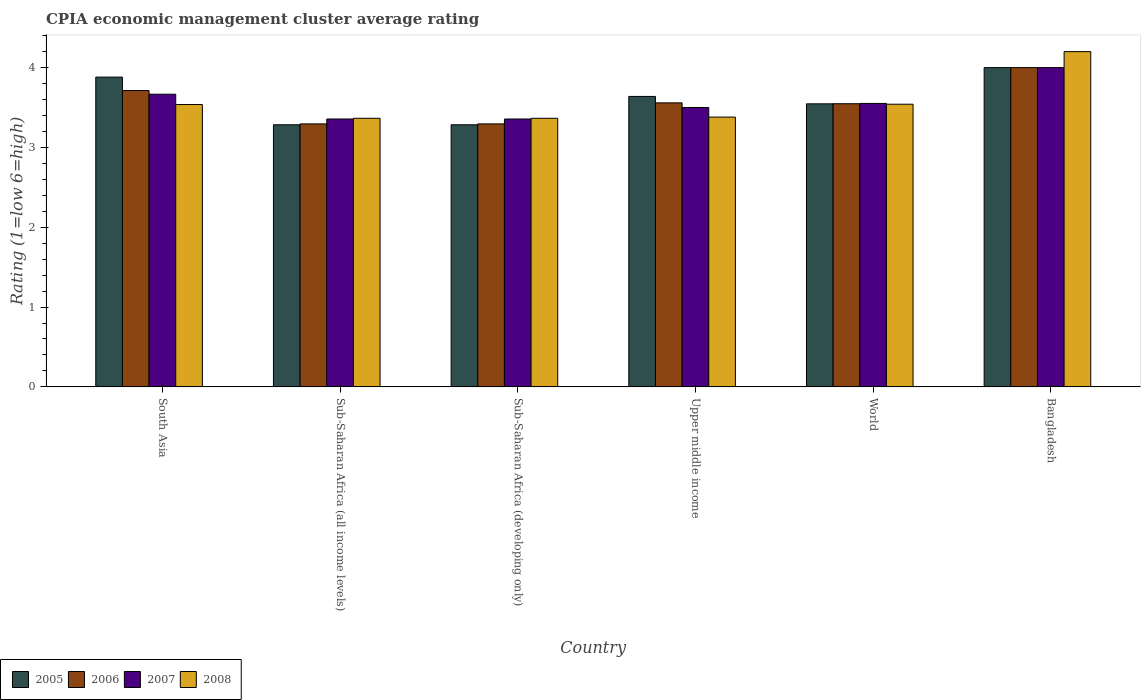How many different coloured bars are there?
Provide a succinct answer. 4. How many groups of bars are there?
Keep it short and to the point. 6. Are the number of bars per tick equal to the number of legend labels?
Your answer should be very brief. Yes. Are the number of bars on each tick of the X-axis equal?
Offer a terse response. Yes. How many bars are there on the 5th tick from the left?
Your response must be concise. 4. How many bars are there on the 2nd tick from the right?
Provide a succinct answer. 4. Across all countries, what is the maximum CPIA rating in 2007?
Your answer should be compact. 4. Across all countries, what is the minimum CPIA rating in 2008?
Make the answer very short. 3.36. In which country was the CPIA rating in 2008 maximum?
Give a very brief answer. Bangladesh. In which country was the CPIA rating in 2006 minimum?
Keep it short and to the point. Sub-Saharan Africa (all income levels). What is the total CPIA rating in 2006 in the graph?
Make the answer very short. 21.41. What is the difference between the CPIA rating in 2005 in South Asia and that in World?
Keep it short and to the point. 0.33. What is the difference between the CPIA rating in 2006 in Sub-Saharan Africa (developing only) and the CPIA rating in 2007 in Bangladesh?
Keep it short and to the point. -0.71. What is the average CPIA rating in 2006 per country?
Ensure brevity in your answer.  3.57. What is the difference between the CPIA rating of/in 2006 and CPIA rating of/in 2005 in Sub-Saharan Africa (developing only)?
Your answer should be compact. 0.01. In how many countries, is the CPIA rating in 2007 greater than 4.2?
Offer a very short reply. 0. What is the ratio of the CPIA rating in 2006 in Bangladesh to that in Sub-Saharan Africa (all income levels)?
Provide a succinct answer. 1.21. Is the CPIA rating in 2007 in South Asia less than that in Sub-Saharan Africa (all income levels)?
Give a very brief answer. No. Is the difference between the CPIA rating in 2006 in South Asia and World greater than the difference between the CPIA rating in 2005 in South Asia and World?
Your response must be concise. No. What is the difference between the highest and the second highest CPIA rating in 2005?
Offer a terse response. -0.24. What is the difference between the highest and the lowest CPIA rating in 2005?
Your answer should be compact. 0.72. Is the sum of the CPIA rating in 2007 in Sub-Saharan Africa (developing only) and Upper middle income greater than the maximum CPIA rating in 2006 across all countries?
Ensure brevity in your answer.  Yes. Is it the case that in every country, the sum of the CPIA rating in 2008 and CPIA rating in 2005 is greater than the sum of CPIA rating in 2007 and CPIA rating in 2006?
Your answer should be very brief. No. Is it the case that in every country, the sum of the CPIA rating in 2008 and CPIA rating in 2006 is greater than the CPIA rating in 2007?
Ensure brevity in your answer.  Yes. What is the difference between two consecutive major ticks on the Y-axis?
Your answer should be compact. 1. How many legend labels are there?
Keep it short and to the point. 4. How are the legend labels stacked?
Your answer should be compact. Horizontal. What is the title of the graph?
Make the answer very short. CPIA economic management cluster average rating. Does "1967" appear as one of the legend labels in the graph?
Ensure brevity in your answer.  No. What is the label or title of the X-axis?
Offer a very short reply. Country. What is the label or title of the Y-axis?
Your answer should be compact. Rating (1=low 6=high). What is the Rating (1=low 6=high) of 2005 in South Asia?
Offer a very short reply. 3.88. What is the Rating (1=low 6=high) in 2006 in South Asia?
Give a very brief answer. 3.71. What is the Rating (1=low 6=high) in 2007 in South Asia?
Ensure brevity in your answer.  3.67. What is the Rating (1=low 6=high) in 2008 in South Asia?
Ensure brevity in your answer.  3.54. What is the Rating (1=low 6=high) in 2005 in Sub-Saharan Africa (all income levels)?
Offer a very short reply. 3.28. What is the Rating (1=low 6=high) of 2006 in Sub-Saharan Africa (all income levels)?
Keep it short and to the point. 3.29. What is the Rating (1=low 6=high) of 2007 in Sub-Saharan Africa (all income levels)?
Make the answer very short. 3.36. What is the Rating (1=low 6=high) in 2008 in Sub-Saharan Africa (all income levels)?
Your answer should be very brief. 3.36. What is the Rating (1=low 6=high) of 2005 in Sub-Saharan Africa (developing only)?
Provide a short and direct response. 3.28. What is the Rating (1=low 6=high) in 2006 in Sub-Saharan Africa (developing only)?
Ensure brevity in your answer.  3.29. What is the Rating (1=low 6=high) in 2007 in Sub-Saharan Africa (developing only)?
Your answer should be compact. 3.36. What is the Rating (1=low 6=high) in 2008 in Sub-Saharan Africa (developing only)?
Provide a short and direct response. 3.36. What is the Rating (1=low 6=high) in 2005 in Upper middle income?
Offer a terse response. 3.64. What is the Rating (1=low 6=high) of 2006 in Upper middle income?
Provide a succinct answer. 3.56. What is the Rating (1=low 6=high) of 2008 in Upper middle income?
Keep it short and to the point. 3.38. What is the Rating (1=low 6=high) in 2005 in World?
Your answer should be very brief. 3.55. What is the Rating (1=low 6=high) in 2006 in World?
Provide a succinct answer. 3.55. What is the Rating (1=low 6=high) of 2007 in World?
Give a very brief answer. 3.55. What is the Rating (1=low 6=high) in 2008 in World?
Your answer should be very brief. 3.54. What is the Rating (1=low 6=high) in 2007 in Bangladesh?
Your response must be concise. 4. What is the Rating (1=low 6=high) of 2008 in Bangladesh?
Give a very brief answer. 4.2. Across all countries, what is the maximum Rating (1=low 6=high) of 2008?
Your answer should be compact. 4.2. Across all countries, what is the minimum Rating (1=low 6=high) in 2005?
Your response must be concise. 3.28. Across all countries, what is the minimum Rating (1=low 6=high) of 2006?
Offer a very short reply. 3.29. Across all countries, what is the minimum Rating (1=low 6=high) of 2007?
Offer a very short reply. 3.36. Across all countries, what is the minimum Rating (1=low 6=high) in 2008?
Your answer should be very brief. 3.36. What is the total Rating (1=low 6=high) in 2005 in the graph?
Make the answer very short. 21.63. What is the total Rating (1=low 6=high) in 2006 in the graph?
Offer a terse response. 21.41. What is the total Rating (1=low 6=high) of 2007 in the graph?
Make the answer very short. 21.43. What is the total Rating (1=low 6=high) in 2008 in the graph?
Give a very brief answer. 21.39. What is the difference between the Rating (1=low 6=high) in 2005 in South Asia and that in Sub-Saharan Africa (all income levels)?
Ensure brevity in your answer.  0.6. What is the difference between the Rating (1=low 6=high) of 2006 in South Asia and that in Sub-Saharan Africa (all income levels)?
Provide a succinct answer. 0.42. What is the difference between the Rating (1=low 6=high) in 2007 in South Asia and that in Sub-Saharan Africa (all income levels)?
Your answer should be very brief. 0.31. What is the difference between the Rating (1=low 6=high) of 2008 in South Asia and that in Sub-Saharan Africa (all income levels)?
Keep it short and to the point. 0.17. What is the difference between the Rating (1=low 6=high) in 2005 in South Asia and that in Sub-Saharan Africa (developing only)?
Your answer should be very brief. 0.6. What is the difference between the Rating (1=low 6=high) in 2006 in South Asia and that in Sub-Saharan Africa (developing only)?
Ensure brevity in your answer.  0.42. What is the difference between the Rating (1=low 6=high) in 2007 in South Asia and that in Sub-Saharan Africa (developing only)?
Your answer should be compact. 0.31. What is the difference between the Rating (1=low 6=high) of 2008 in South Asia and that in Sub-Saharan Africa (developing only)?
Make the answer very short. 0.17. What is the difference between the Rating (1=low 6=high) in 2005 in South Asia and that in Upper middle income?
Provide a short and direct response. 0.24. What is the difference between the Rating (1=low 6=high) of 2006 in South Asia and that in Upper middle income?
Keep it short and to the point. 0.15. What is the difference between the Rating (1=low 6=high) in 2008 in South Asia and that in Upper middle income?
Provide a short and direct response. 0.16. What is the difference between the Rating (1=low 6=high) in 2005 in South Asia and that in World?
Provide a succinct answer. 0.33. What is the difference between the Rating (1=low 6=high) of 2006 in South Asia and that in World?
Keep it short and to the point. 0.17. What is the difference between the Rating (1=low 6=high) of 2007 in South Asia and that in World?
Offer a terse response. 0.12. What is the difference between the Rating (1=low 6=high) of 2008 in South Asia and that in World?
Offer a very short reply. -0. What is the difference between the Rating (1=low 6=high) of 2005 in South Asia and that in Bangladesh?
Your answer should be very brief. -0.12. What is the difference between the Rating (1=low 6=high) of 2006 in South Asia and that in Bangladesh?
Your answer should be very brief. -0.29. What is the difference between the Rating (1=low 6=high) in 2007 in South Asia and that in Bangladesh?
Provide a short and direct response. -0.33. What is the difference between the Rating (1=low 6=high) of 2008 in South Asia and that in Bangladesh?
Your answer should be very brief. -0.66. What is the difference between the Rating (1=low 6=high) of 2006 in Sub-Saharan Africa (all income levels) and that in Sub-Saharan Africa (developing only)?
Your response must be concise. 0. What is the difference between the Rating (1=low 6=high) in 2005 in Sub-Saharan Africa (all income levels) and that in Upper middle income?
Offer a very short reply. -0.36. What is the difference between the Rating (1=low 6=high) of 2006 in Sub-Saharan Africa (all income levels) and that in Upper middle income?
Offer a very short reply. -0.26. What is the difference between the Rating (1=low 6=high) in 2007 in Sub-Saharan Africa (all income levels) and that in Upper middle income?
Offer a terse response. -0.14. What is the difference between the Rating (1=low 6=high) of 2008 in Sub-Saharan Africa (all income levels) and that in Upper middle income?
Make the answer very short. -0.02. What is the difference between the Rating (1=low 6=high) of 2005 in Sub-Saharan Africa (all income levels) and that in World?
Offer a very short reply. -0.26. What is the difference between the Rating (1=low 6=high) in 2006 in Sub-Saharan Africa (all income levels) and that in World?
Ensure brevity in your answer.  -0.25. What is the difference between the Rating (1=low 6=high) of 2007 in Sub-Saharan Africa (all income levels) and that in World?
Offer a very short reply. -0.2. What is the difference between the Rating (1=low 6=high) of 2008 in Sub-Saharan Africa (all income levels) and that in World?
Make the answer very short. -0.18. What is the difference between the Rating (1=low 6=high) in 2005 in Sub-Saharan Africa (all income levels) and that in Bangladesh?
Make the answer very short. -0.72. What is the difference between the Rating (1=low 6=high) in 2006 in Sub-Saharan Africa (all income levels) and that in Bangladesh?
Your answer should be compact. -0.71. What is the difference between the Rating (1=low 6=high) of 2007 in Sub-Saharan Africa (all income levels) and that in Bangladesh?
Your response must be concise. -0.64. What is the difference between the Rating (1=low 6=high) in 2008 in Sub-Saharan Africa (all income levels) and that in Bangladesh?
Keep it short and to the point. -0.84. What is the difference between the Rating (1=low 6=high) of 2005 in Sub-Saharan Africa (developing only) and that in Upper middle income?
Your answer should be very brief. -0.36. What is the difference between the Rating (1=low 6=high) of 2006 in Sub-Saharan Africa (developing only) and that in Upper middle income?
Provide a succinct answer. -0.26. What is the difference between the Rating (1=low 6=high) of 2007 in Sub-Saharan Africa (developing only) and that in Upper middle income?
Keep it short and to the point. -0.14. What is the difference between the Rating (1=low 6=high) in 2008 in Sub-Saharan Africa (developing only) and that in Upper middle income?
Your answer should be compact. -0.02. What is the difference between the Rating (1=low 6=high) of 2005 in Sub-Saharan Africa (developing only) and that in World?
Your answer should be compact. -0.26. What is the difference between the Rating (1=low 6=high) in 2006 in Sub-Saharan Africa (developing only) and that in World?
Offer a terse response. -0.25. What is the difference between the Rating (1=low 6=high) in 2007 in Sub-Saharan Africa (developing only) and that in World?
Provide a short and direct response. -0.2. What is the difference between the Rating (1=low 6=high) of 2008 in Sub-Saharan Africa (developing only) and that in World?
Provide a short and direct response. -0.18. What is the difference between the Rating (1=low 6=high) of 2005 in Sub-Saharan Africa (developing only) and that in Bangladesh?
Offer a terse response. -0.72. What is the difference between the Rating (1=low 6=high) in 2006 in Sub-Saharan Africa (developing only) and that in Bangladesh?
Keep it short and to the point. -0.71. What is the difference between the Rating (1=low 6=high) in 2007 in Sub-Saharan Africa (developing only) and that in Bangladesh?
Keep it short and to the point. -0.64. What is the difference between the Rating (1=low 6=high) in 2008 in Sub-Saharan Africa (developing only) and that in Bangladesh?
Offer a very short reply. -0.84. What is the difference between the Rating (1=low 6=high) in 2005 in Upper middle income and that in World?
Offer a terse response. 0.09. What is the difference between the Rating (1=low 6=high) in 2006 in Upper middle income and that in World?
Your answer should be compact. 0.01. What is the difference between the Rating (1=low 6=high) of 2007 in Upper middle income and that in World?
Offer a very short reply. -0.05. What is the difference between the Rating (1=low 6=high) of 2008 in Upper middle income and that in World?
Provide a succinct answer. -0.16. What is the difference between the Rating (1=low 6=high) in 2005 in Upper middle income and that in Bangladesh?
Provide a succinct answer. -0.36. What is the difference between the Rating (1=low 6=high) of 2006 in Upper middle income and that in Bangladesh?
Your answer should be compact. -0.44. What is the difference between the Rating (1=low 6=high) of 2007 in Upper middle income and that in Bangladesh?
Your response must be concise. -0.5. What is the difference between the Rating (1=low 6=high) of 2008 in Upper middle income and that in Bangladesh?
Provide a succinct answer. -0.82. What is the difference between the Rating (1=low 6=high) in 2005 in World and that in Bangladesh?
Provide a short and direct response. -0.45. What is the difference between the Rating (1=low 6=high) in 2006 in World and that in Bangladesh?
Offer a terse response. -0.45. What is the difference between the Rating (1=low 6=high) in 2007 in World and that in Bangladesh?
Provide a short and direct response. -0.45. What is the difference between the Rating (1=low 6=high) in 2008 in World and that in Bangladesh?
Give a very brief answer. -0.66. What is the difference between the Rating (1=low 6=high) of 2005 in South Asia and the Rating (1=low 6=high) of 2006 in Sub-Saharan Africa (all income levels)?
Ensure brevity in your answer.  0.59. What is the difference between the Rating (1=low 6=high) in 2005 in South Asia and the Rating (1=low 6=high) in 2007 in Sub-Saharan Africa (all income levels)?
Make the answer very short. 0.53. What is the difference between the Rating (1=low 6=high) of 2005 in South Asia and the Rating (1=low 6=high) of 2008 in Sub-Saharan Africa (all income levels)?
Provide a short and direct response. 0.52. What is the difference between the Rating (1=low 6=high) of 2006 in South Asia and the Rating (1=low 6=high) of 2007 in Sub-Saharan Africa (all income levels)?
Make the answer very short. 0.36. What is the difference between the Rating (1=low 6=high) of 2006 in South Asia and the Rating (1=low 6=high) of 2008 in Sub-Saharan Africa (all income levels)?
Provide a succinct answer. 0.35. What is the difference between the Rating (1=low 6=high) of 2007 in South Asia and the Rating (1=low 6=high) of 2008 in Sub-Saharan Africa (all income levels)?
Provide a short and direct response. 0.3. What is the difference between the Rating (1=low 6=high) in 2005 in South Asia and the Rating (1=low 6=high) in 2006 in Sub-Saharan Africa (developing only)?
Make the answer very short. 0.59. What is the difference between the Rating (1=low 6=high) in 2005 in South Asia and the Rating (1=low 6=high) in 2007 in Sub-Saharan Africa (developing only)?
Your response must be concise. 0.53. What is the difference between the Rating (1=low 6=high) of 2005 in South Asia and the Rating (1=low 6=high) of 2008 in Sub-Saharan Africa (developing only)?
Keep it short and to the point. 0.52. What is the difference between the Rating (1=low 6=high) of 2006 in South Asia and the Rating (1=low 6=high) of 2007 in Sub-Saharan Africa (developing only)?
Keep it short and to the point. 0.36. What is the difference between the Rating (1=low 6=high) of 2006 in South Asia and the Rating (1=low 6=high) of 2008 in Sub-Saharan Africa (developing only)?
Provide a succinct answer. 0.35. What is the difference between the Rating (1=low 6=high) of 2007 in South Asia and the Rating (1=low 6=high) of 2008 in Sub-Saharan Africa (developing only)?
Ensure brevity in your answer.  0.3. What is the difference between the Rating (1=low 6=high) in 2005 in South Asia and the Rating (1=low 6=high) in 2006 in Upper middle income?
Make the answer very short. 0.32. What is the difference between the Rating (1=low 6=high) of 2005 in South Asia and the Rating (1=low 6=high) of 2007 in Upper middle income?
Your answer should be very brief. 0.38. What is the difference between the Rating (1=low 6=high) in 2005 in South Asia and the Rating (1=low 6=high) in 2008 in Upper middle income?
Give a very brief answer. 0.5. What is the difference between the Rating (1=low 6=high) in 2006 in South Asia and the Rating (1=low 6=high) in 2007 in Upper middle income?
Ensure brevity in your answer.  0.21. What is the difference between the Rating (1=low 6=high) in 2006 in South Asia and the Rating (1=low 6=high) in 2008 in Upper middle income?
Provide a short and direct response. 0.33. What is the difference between the Rating (1=low 6=high) of 2007 in South Asia and the Rating (1=low 6=high) of 2008 in Upper middle income?
Offer a very short reply. 0.29. What is the difference between the Rating (1=low 6=high) of 2005 in South Asia and the Rating (1=low 6=high) of 2006 in World?
Ensure brevity in your answer.  0.33. What is the difference between the Rating (1=low 6=high) in 2005 in South Asia and the Rating (1=low 6=high) in 2007 in World?
Provide a succinct answer. 0.33. What is the difference between the Rating (1=low 6=high) in 2005 in South Asia and the Rating (1=low 6=high) in 2008 in World?
Provide a short and direct response. 0.34. What is the difference between the Rating (1=low 6=high) of 2006 in South Asia and the Rating (1=low 6=high) of 2007 in World?
Your response must be concise. 0.16. What is the difference between the Rating (1=low 6=high) of 2006 in South Asia and the Rating (1=low 6=high) of 2008 in World?
Give a very brief answer. 0.17. What is the difference between the Rating (1=low 6=high) of 2007 in South Asia and the Rating (1=low 6=high) of 2008 in World?
Keep it short and to the point. 0.13. What is the difference between the Rating (1=low 6=high) of 2005 in South Asia and the Rating (1=low 6=high) of 2006 in Bangladesh?
Your answer should be compact. -0.12. What is the difference between the Rating (1=low 6=high) of 2005 in South Asia and the Rating (1=low 6=high) of 2007 in Bangladesh?
Ensure brevity in your answer.  -0.12. What is the difference between the Rating (1=low 6=high) of 2005 in South Asia and the Rating (1=low 6=high) of 2008 in Bangladesh?
Ensure brevity in your answer.  -0.32. What is the difference between the Rating (1=low 6=high) in 2006 in South Asia and the Rating (1=low 6=high) in 2007 in Bangladesh?
Give a very brief answer. -0.29. What is the difference between the Rating (1=low 6=high) of 2006 in South Asia and the Rating (1=low 6=high) of 2008 in Bangladesh?
Ensure brevity in your answer.  -0.49. What is the difference between the Rating (1=low 6=high) in 2007 in South Asia and the Rating (1=low 6=high) in 2008 in Bangladesh?
Offer a terse response. -0.53. What is the difference between the Rating (1=low 6=high) in 2005 in Sub-Saharan Africa (all income levels) and the Rating (1=low 6=high) in 2006 in Sub-Saharan Africa (developing only)?
Your answer should be compact. -0.01. What is the difference between the Rating (1=low 6=high) in 2005 in Sub-Saharan Africa (all income levels) and the Rating (1=low 6=high) in 2007 in Sub-Saharan Africa (developing only)?
Offer a very short reply. -0.07. What is the difference between the Rating (1=low 6=high) of 2005 in Sub-Saharan Africa (all income levels) and the Rating (1=low 6=high) of 2008 in Sub-Saharan Africa (developing only)?
Offer a very short reply. -0.08. What is the difference between the Rating (1=low 6=high) of 2006 in Sub-Saharan Africa (all income levels) and the Rating (1=low 6=high) of 2007 in Sub-Saharan Africa (developing only)?
Make the answer very short. -0.06. What is the difference between the Rating (1=low 6=high) of 2006 in Sub-Saharan Africa (all income levels) and the Rating (1=low 6=high) of 2008 in Sub-Saharan Africa (developing only)?
Keep it short and to the point. -0.07. What is the difference between the Rating (1=low 6=high) of 2007 in Sub-Saharan Africa (all income levels) and the Rating (1=low 6=high) of 2008 in Sub-Saharan Africa (developing only)?
Your answer should be compact. -0.01. What is the difference between the Rating (1=low 6=high) of 2005 in Sub-Saharan Africa (all income levels) and the Rating (1=low 6=high) of 2006 in Upper middle income?
Offer a very short reply. -0.27. What is the difference between the Rating (1=low 6=high) in 2005 in Sub-Saharan Africa (all income levels) and the Rating (1=low 6=high) in 2007 in Upper middle income?
Provide a succinct answer. -0.22. What is the difference between the Rating (1=low 6=high) in 2005 in Sub-Saharan Africa (all income levels) and the Rating (1=low 6=high) in 2008 in Upper middle income?
Provide a short and direct response. -0.1. What is the difference between the Rating (1=low 6=high) in 2006 in Sub-Saharan Africa (all income levels) and the Rating (1=low 6=high) in 2007 in Upper middle income?
Offer a terse response. -0.21. What is the difference between the Rating (1=low 6=high) in 2006 in Sub-Saharan Africa (all income levels) and the Rating (1=low 6=high) in 2008 in Upper middle income?
Your response must be concise. -0.09. What is the difference between the Rating (1=low 6=high) of 2007 in Sub-Saharan Africa (all income levels) and the Rating (1=low 6=high) of 2008 in Upper middle income?
Your response must be concise. -0.02. What is the difference between the Rating (1=low 6=high) in 2005 in Sub-Saharan Africa (all income levels) and the Rating (1=low 6=high) in 2006 in World?
Ensure brevity in your answer.  -0.26. What is the difference between the Rating (1=low 6=high) of 2005 in Sub-Saharan Africa (all income levels) and the Rating (1=low 6=high) of 2007 in World?
Give a very brief answer. -0.27. What is the difference between the Rating (1=low 6=high) of 2005 in Sub-Saharan Africa (all income levels) and the Rating (1=low 6=high) of 2008 in World?
Provide a short and direct response. -0.26. What is the difference between the Rating (1=low 6=high) of 2006 in Sub-Saharan Africa (all income levels) and the Rating (1=low 6=high) of 2007 in World?
Your answer should be compact. -0.26. What is the difference between the Rating (1=low 6=high) of 2006 in Sub-Saharan Africa (all income levels) and the Rating (1=low 6=high) of 2008 in World?
Your response must be concise. -0.25. What is the difference between the Rating (1=low 6=high) of 2007 in Sub-Saharan Africa (all income levels) and the Rating (1=low 6=high) of 2008 in World?
Make the answer very short. -0.19. What is the difference between the Rating (1=low 6=high) of 2005 in Sub-Saharan Africa (all income levels) and the Rating (1=low 6=high) of 2006 in Bangladesh?
Your response must be concise. -0.72. What is the difference between the Rating (1=low 6=high) of 2005 in Sub-Saharan Africa (all income levels) and the Rating (1=low 6=high) of 2007 in Bangladesh?
Your answer should be very brief. -0.72. What is the difference between the Rating (1=low 6=high) of 2005 in Sub-Saharan Africa (all income levels) and the Rating (1=low 6=high) of 2008 in Bangladesh?
Make the answer very short. -0.92. What is the difference between the Rating (1=low 6=high) in 2006 in Sub-Saharan Africa (all income levels) and the Rating (1=low 6=high) in 2007 in Bangladesh?
Provide a short and direct response. -0.71. What is the difference between the Rating (1=low 6=high) in 2006 in Sub-Saharan Africa (all income levels) and the Rating (1=low 6=high) in 2008 in Bangladesh?
Make the answer very short. -0.91. What is the difference between the Rating (1=low 6=high) of 2007 in Sub-Saharan Africa (all income levels) and the Rating (1=low 6=high) of 2008 in Bangladesh?
Keep it short and to the point. -0.84. What is the difference between the Rating (1=low 6=high) in 2005 in Sub-Saharan Africa (developing only) and the Rating (1=low 6=high) in 2006 in Upper middle income?
Offer a very short reply. -0.27. What is the difference between the Rating (1=low 6=high) in 2005 in Sub-Saharan Africa (developing only) and the Rating (1=low 6=high) in 2007 in Upper middle income?
Your response must be concise. -0.22. What is the difference between the Rating (1=low 6=high) in 2005 in Sub-Saharan Africa (developing only) and the Rating (1=low 6=high) in 2008 in Upper middle income?
Ensure brevity in your answer.  -0.1. What is the difference between the Rating (1=low 6=high) of 2006 in Sub-Saharan Africa (developing only) and the Rating (1=low 6=high) of 2007 in Upper middle income?
Keep it short and to the point. -0.21. What is the difference between the Rating (1=low 6=high) in 2006 in Sub-Saharan Africa (developing only) and the Rating (1=low 6=high) in 2008 in Upper middle income?
Offer a terse response. -0.09. What is the difference between the Rating (1=low 6=high) of 2007 in Sub-Saharan Africa (developing only) and the Rating (1=low 6=high) of 2008 in Upper middle income?
Make the answer very short. -0.02. What is the difference between the Rating (1=low 6=high) in 2005 in Sub-Saharan Africa (developing only) and the Rating (1=low 6=high) in 2006 in World?
Offer a terse response. -0.26. What is the difference between the Rating (1=low 6=high) of 2005 in Sub-Saharan Africa (developing only) and the Rating (1=low 6=high) of 2007 in World?
Offer a terse response. -0.27. What is the difference between the Rating (1=low 6=high) of 2005 in Sub-Saharan Africa (developing only) and the Rating (1=low 6=high) of 2008 in World?
Provide a succinct answer. -0.26. What is the difference between the Rating (1=low 6=high) of 2006 in Sub-Saharan Africa (developing only) and the Rating (1=low 6=high) of 2007 in World?
Your answer should be compact. -0.26. What is the difference between the Rating (1=low 6=high) in 2006 in Sub-Saharan Africa (developing only) and the Rating (1=low 6=high) in 2008 in World?
Provide a short and direct response. -0.25. What is the difference between the Rating (1=low 6=high) in 2007 in Sub-Saharan Africa (developing only) and the Rating (1=low 6=high) in 2008 in World?
Give a very brief answer. -0.19. What is the difference between the Rating (1=low 6=high) in 2005 in Sub-Saharan Africa (developing only) and the Rating (1=low 6=high) in 2006 in Bangladesh?
Keep it short and to the point. -0.72. What is the difference between the Rating (1=low 6=high) in 2005 in Sub-Saharan Africa (developing only) and the Rating (1=low 6=high) in 2007 in Bangladesh?
Keep it short and to the point. -0.72. What is the difference between the Rating (1=low 6=high) of 2005 in Sub-Saharan Africa (developing only) and the Rating (1=low 6=high) of 2008 in Bangladesh?
Ensure brevity in your answer.  -0.92. What is the difference between the Rating (1=low 6=high) in 2006 in Sub-Saharan Africa (developing only) and the Rating (1=low 6=high) in 2007 in Bangladesh?
Your response must be concise. -0.71. What is the difference between the Rating (1=low 6=high) of 2006 in Sub-Saharan Africa (developing only) and the Rating (1=low 6=high) of 2008 in Bangladesh?
Offer a terse response. -0.91. What is the difference between the Rating (1=low 6=high) in 2007 in Sub-Saharan Africa (developing only) and the Rating (1=low 6=high) in 2008 in Bangladesh?
Provide a succinct answer. -0.84. What is the difference between the Rating (1=low 6=high) of 2005 in Upper middle income and the Rating (1=low 6=high) of 2006 in World?
Provide a short and direct response. 0.09. What is the difference between the Rating (1=low 6=high) of 2005 in Upper middle income and the Rating (1=low 6=high) of 2007 in World?
Your response must be concise. 0.09. What is the difference between the Rating (1=low 6=high) of 2005 in Upper middle income and the Rating (1=low 6=high) of 2008 in World?
Your response must be concise. 0.1. What is the difference between the Rating (1=low 6=high) of 2006 in Upper middle income and the Rating (1=low 6=high) of 2007 in World?
Give a very brief answer. 0.01. What is the difference between the Rating (1=low 6=high) of 2006 in Upper middle income and the Rating (1=low 6=high) of 2008 in World?
Ensure brevity in your answer.  0.02. What is the difference between the Rating (1=low 6=high) in 2007 in Upper middle income and the Rating (1=low 6=high) in 2008 in World?
Make the answer very short. -0.04. What is the difference between the Rating (1=low 6=high) in 2005 in Upper middle income and the Rating (1=low 6=high) in 2006 in Bangladesh?
Provide a succinct answer. -0.36. What is the difference between the Rating (1=low 6=high) in 2005 in Upper middle income and the Rating (1=low 6=high) in 2007 in Bangladesh?
Make the answer very short. -0.36. What is the difference between the Rating (1=low 6=high) in 2005 in Upper middle income and the Rating (1=low 6=high) in 2008 in Bangladesh?
Keep it short and to the point. -0.56. What is the difference between the Rating (1=low 6=high) of 2006 in Upper middle income and the Rating (1=low 6=high) of 2007 in Bangladesh?
Provide a short and direct response. -0.44. What is the difference between the Rating (1=low 6=high) in 2006 in Upper middle income and the Rating (1=low 6=high) in 2008 in Bangladesh?
Your answer should be very brief. -0.64. What is the difference between the Rating (1=low 6=high) in 2007 in Upper middle income and the Rating (1=low 6=high) in 2008 in Bangladesh?
Offer a terse response. -0.7. What is the difference between the Rating (1=low 6=high) in 2005 in World and the Rating (1=low 6=high) in 2006 in Bangladesh?
Give a very brief answer. -0.45. What is the difference between the Rating (1=low 6=high) of 2005 in World and the Rating (1=low 6=high) of 2007 in Bangladesh?
Your answer should be compact. -0.45. What is the difference between the Rating (1=low 6=high) of 2005 in World and the Rating (1=low 6=high) of 2008 in Bangladesh?
Make the answer very short. -0.65. What is the difference between the Rating (1=low 6=high) of 2006 in World and the Rating (1=low 6=high) of 2007 in Bangladesh?
Provide a short and direct response. -0.45. What is the difference between the Rating (1=low 6=high) in 2006 in World and the Rating (1=low 6=high) in 2008 in Bangladesh?
Offer a very short reply. -0.65. What is the difference between the Rating (1=low 6=high) in 2007 in World and the Rating (1=low 6=high) in 2008 in Bangladesh?
Your response must be concise. -0.65. What is the average Rating (1=low 6=high) in 2005 per country?
Provide a succinct answer. 3.61. What is the average Rating (1=low 6=high) of 2006 per country?
Your answer should be very brief. 3.57. What is the average Rating (1=low 6=high) in 2007 per country?
Ensure brevity in your answer.  3.57. What is the average Rating (1=low 6=high) of 2008 per country?
Ensure brevity in your answer.  3.56. What is the difference between the Rating (1=low 6=high) of 2005 and Rating (1=low 6=high) of 2006 in South Asia?
Ensure brevity in your answer.  0.17. What is the difference between the Rating (1=low 6=high) in 2005 and Rating (1=low 6=high) in 2007 in South Asia?
Give a very brief answer. 0.21. What is the difference between the Rating (1=low 6=high) in 2005 and Rating (1=low 6=high) in 2008 in South Asia?
Give a very brief answer. 0.34. What is the difference between the Rating (1=low 6=high) in 2006 and Rating (1=low 6=high) in 2007 in South Asia?
Offer a very short reply. 0.05. What is the difference between the Rating (1=low 6=high) in 2006 and Rating (1=low 6=high) in 2008 in South Asia?
Offer a terse response. 0.17. What is the difference between the Rating (1=low 6=high) of 2007 and Rating (1=low 6=high) of 2008 in South Asia?
Your answer should be very brief. 0.13. What is the difference between the Rating (1=low 6=high) in 2005 and Rating (1=low 6=high) in 2006 in Sub-Saharan Africa (all income levels)?
Give a very brief answer. -0.01. What is the difference between the Rating (1=low 6=high) of 2005 and Rating (1=low 6=high) of 2007 in Sub-Saharan Africa (all income levels)?
Provide a succinct answer. -0.07. What is the difference between the Rating (1=low 6=high) of 2005 and Rating (1=low 6=high) of 2008 in Sub-Saharan Africa (all income levels)?
Keep it short and to the point. -0.08. What is the difference between the Rating (1=low 6=high) in 2006 and Rating (1=low 6=high) in 2007 in Sub-Saharan Africa (all income levels)?
Provide a succinct answer. -0.06. What is the difference between the Rating (1=low 6=high) in 2006 and Rating (1=low 6=high) in 2008 in Sub-Saharan Africa (all income levels)?
Make the answer very short. -0.07. What is the difference between the Rating (1=low 6=high) of 2007 and Rating (1=low 6=high) of 2008 in Sub-Saharan Africa (all income levels)?
Your response must be concise. -0.01. What is the difference between the Rating (1=low 6=high) of 2005 and Rating (1=low 6=high) of 2006 in Sub-Saharan Africa (developing only)?
Ensure brevity in your answer.  -0.01. What is the difference between the Rating (1=low 6=high) of 2005 and Rating (1=low 6=high) of 2007 in Sub-Saharan Africa (developing only)?
Ensure brevity in your answer.  -0.07. What is the difference between the Rating (1=low 6=high) of 2005 and Rating (1=low 6=high) of 2008 in Sub-Saharan Africa (developing only)?
Give a very brief answer. -0.08. What is the difference between the Rating (1=low 6=high) of 2006 and Rating (1=low 6=high) of 2007 in Sub-Saharan Africa (developing only)?
Ensure brevity in your answer.  -0.06. What is the difference between the Rating (1=low 6=high) in 2006 and Rating (1=low 6=high) in 2008 in Sub-Saharan Africa (developing only)?
Ensure brevity in your answer.  -0.07. What is the difference between the Rating (1=low 6=high) of 2007 and Rating (1=low 6=high) of 2008 in Sub-Saharan Africa (developing only)?
Give a very brief answer. -0.01. What is the difference between the Rating (1=low 6=high) of 2005 and Rating (1=low 6=high) of 2006 in Upper middle income?
Your answer should be very brief. 0.08. What is the difference between the Rating (1=low 6=high) in 2005 and Rating (1=low 6=high) in 2007 in Upper middle income?
Offer a very short reply. 0.14. What is the difference between the Rating (1=low 6=high) in 2005 and Rating (1=low 6=high) in 2008 in Upper middle income?
Your answer should be very brief. 0.26. What is the difference between the Rating (1=low 6=high) of 2006 and Rating (1=low 6=high) of 2007 in Upper middle income?
Provide a short and direct response. 0.06. What is the difference between the Rating (1=low 6=high) of 2006 and Rating (1=low 6=high) of 2008 in Upper middle income?
Offer a very short reply. 0.18. What is the difference between the Rating (1=low 6=high) in 2007 and Rating (1=low 6=high) in 2008 in Upper middle income?
Give a very brief answer. 0.12. What is the difference between the Rating (1=low 6=high) of 2005 and Rating (1=low 6=high) of 2006 in World?
Your answer should be very brief. -0. What is the difference between the Rating (1=low 6=high) in 2005 and Rating (1=low 6=high) in 2007 in World?
Make the answer very short. -0.01. What is the difference between the Rating (1=low 6=high) in 2005 and Rating (1=low 6=high) in 2008 in World?
Give a very brief answer. 0. What is the difference between the Rating (1=low 6=high) in 2006 and Rating (1=low 6=high) in 2007 in World?
Keep it short and to the point. -0. What is the difference between the Rating (1=low 6=high) in 2006 and Rating (1=low 6=high) in 2008 in World?
Your answer should be compact. 0.01. What is the difference between the Rating (1=low 6=high) in 2007 and Rating (1=low 6=high) in 2008 in World?
Provide a short and direct response. 0.01. What is the difference between the Rating (1=low 6=high) of 2005 and Rating (1=low 6=high) of 2006 in Bangladesh?
Offer a terse response. 0. What is the difference between the Rating (1=low 6=high) of 2005 and Rating (1=low 6=high) of 2008 in Bangladesh?
Your answer should be very brief. -0.2. What is the ratio of the Rating (1=low 6=high) of 2005 in South Asia to that in Sub-Saharan Africa (all income levels)?
Offer a terse response. 1.18. What is the ratio of the Rating (1=low 6=high) in 2006 in South Asia to that in Sub-Saharan Africa (all income levels)?
Make the answer very short. 1.13. What is the ratio of the Rating (1=low 6=high) of 2007 in South Asia to that in Sub-Saharan Africa (all income levels)?
Offer a terse response. 1.09. What is the ratio of the Rating (1=low 6=high) in 2008 in South Asia to that in Sub-Saharan Africa (all income levels)?
Provide a succinct answer. 1.05. What is the ratio of the Rating (1=low 6=high) in 2005 in South Asia to that in Sub-Saharan Africa (developing only)?
Your response must be concise. 1.18. What is the ratio of the Rating (1=low 6=high) of 2006 in South Asia to that in Sub-Saharan Africa (developing only)?
Your answer should be compact. 1.13. What is the ratio of the Rating (1=low 6=high) in 2007 in South Asia to that in Sub-Saharan Africa (developing only)?
Provide a succinct answer. 1.09. What is the ratio of the Rating (1=low 6=high) of 2008 in South Asia to that in Sub-Saharan Africa (developing only)?
Offer a very short reply. 1.05. What is the ratio of the Rating (1=low 6=high) of 2005 in South Asia to that in Upper middle income?
Offer a very short reply. 1.07. What is the ratio of the Rating (1=low 6=high) in 2006 in South Asia to that in Upper middle income?
Your answer should be compact. 1.04. What is the ratio of the Rating (1=low 6=high) in 2007 in South Asia to that in Upper middle income?
Ensure brevity in your answer.  1.05. What is the ratio of the Rating (1=low 6=high) in 2008 in South Asia to that in Upper middle income?
Offer a very short reply. 1.05. What is the ratio of the Rating (1=low 6=high) in 2005 in South Asia to that in World?
Give a very brief answer. 1.09. What is the ratio of the Rating (1=low 6=high) in 2006 in South Asia to that in World?
Make the answer very short. 1.05. What is the ratio of the Rating (1=low 6=high) in 2007 in South Asia to that in World?
Provide a succinct answer. 1.03. What is the ratio of the Rating (1=low 6=high) of 2008 in South Asia to that in World?
Ensure brevity in your answer.  1. What is the ratio of the Rating (1=low 6=high) in 2005 in South Asia to that in Bangladesh?
Keep it short and to the point. 0.97. What is the ratio of the Rating (1=low 6=high) in 2006 in South Asia to that in Bangladesh?
Make the answer very short. 0.93. What is the ratio of the Rating (1=low 6=high) in 2007 in South Asia to that in Bangladesh?
Make the answer very short. 0.92. What is the ratio of the Rating (1=low 6=high) in 2008 in South Asia to that in Bangladesh?
Your answer should be compact. 0.84. What is the ratio of the Rating (1=low 6=high) in 2005 in Sub-Saharan Africa (all income levels) to that in Sub-Saharan Africa (developing only)?
Provide a succinct answer. 1. What is the ratio of the Rating (1=low 6=high) in 2006 in Sub-Saharan Africa (all income levels) to that in Sub-Saharan Africa (developing only)?
Your answer should be very brief. 1. What is the ratio of the Rating (1=low 6=high) in 2007 in Sub-Saharan Africa (all income levels) to that in Sub-Saharan Africa (developing only)?
Provide a succinct answer. 1. What is the ratio of the Rating (1=low 6=high) in 2005 in Sub-Saharan Africa (all income levels) to that in Upper middle income?
Offer a very short reply. 0.9. What is the ratio of the Rating (1=low 6=high) in 2006 in Sub-Saharan Africa (all income levels) to that in Upper middle income?
Make the answer very short. 0.93. What is the ratio of the Rating (1=low 6=high) in 2007 in Sub-Saharan Africa (all income levels) to that in Upper middle income?
Offer a very short reply. 0.96. What is the ratio of the Rating (1=low 6=high) of 2008 in Sub-Saharan Africa (all income levels) to that in Upper middle income?
Make the answer very short. 1. What is the ratio of the Rating (1=low 6=high) of 2005 in Sub-Saharan Africa (all income levels) to that in World?
Keep it short and to the point. 0.93. What is the ratio of the Rating (1=low 6=high) in 2006 in Sub-Saharan Africa (all income levels) to that in World?
Give a very brief answer. 0.93. What is the ratio of the Rating (1=low 6=high) of 2007 in Sub-Saharan Africa (all income levels) to that in World?
Your answer should be very brief. 0.94. What is the ratio of the Rating (1=low 6=high) of 2008 in Sub-Saharan Africa (all income levels) to that in World?
Your answer should be very brief. 0.95. What is the ratio of the Rating (1=low 6=high) of 2005 in Sub-Saharan Africa (all income levels) to that in Bangladesh?
Your answer should be compact. 0.82. What is the ratio of the Rating (1=low 6=high) in 2006 in Sub-Saharan Africa (all income levels) to that in Bangladesh?
Your response must be concise. 0.82. What is the ratio of the Rating (1=low 6=high) of 2007 in Sub-Saharan Africa (all income levels) to that in Bangladesh?
Give a very brief answer. 0.84. What is the ratio of the Rating (1=low 6=high) in 2008 in Sub-Saharan Africa (all income levels) to that in Bangladesh?
Keep it short and to the point. 0.8. What is the ratio of the Rating (1=low 6=high) of 2005 in Sub-Saharan Africa (developing only) to that in Upper middle income?
Provide a succinct answer. 0.9. What is the ratio of the Rating (1=low 6=high) in 2006 in Sub-Saharan Africa (developing only) to that in Upper middle income?
Your answer should be compact. 0.93. What is the ratio of the Rating (1=low 6=high) of 2007 in Sub-Saharan Africa (developing only) to that in Upper middle income?
Your response must be concise. 0.96. What is the ratio of the Rating (1=low 6=high) of 2005 in Sub-Saharan Africa (developing only) to that in World?
Keep it short and to the point. 0.93. What is the ratio of the Rating (1=low 6=high) in 2006 in Sub-Saharan Africa (developing only) to that in World?
Your response must be concise. 0.93. What is the ratio of the Rating (1=low 6=high) of 2007 in Sub-Saharan Africa (developing only) to that in World?
Your response must be concise. 0.94. What is the ratio of the Rating (1=low 6=high) of 2008 in Sub-Saharan Africa (developing only) to that in World?
Give a very brief answer. 0.95. What is the ratio of the Rating (1=low 6=high) in 2005 in Sub-Saharan Africa (developing only) to that in Bangladesh?
Your response must be concise. 0.82. What is the ratio of the Rating (1=low 6=high) of 2006 in Sub-Saharan Africa (developing only) to that in Bangladesh?
Offer a very short reply. 0.82. What is the ratio of the Rating (1=low 6=high) of 2007 in Sub-Saharan Africa (developing only) to that in Bangladesh?
Your response must be concise. 0.84. What is the ratio of the Rating (1=low 6=high) in 2008 in Sub-Saharan Africa (developing only) to that in Bangladesh?
Offer a terse response. 0.8. What is the ratio of the Rating (1=low 6=high) in 2005 in Upper middle income to that in World?
Offer a terse response. 1.03. What is the ratio of the Rating (1=low 6=high) of 2007 in Upper middle income to that in World?
Make the answer very short. 0.99. What is the ratio of the Rating (1=low 6=high) of 2008 in Upper middle income to that in World?
Provide a short and direct response. 0.95. What is the ratio of the Rating (1=low 6=high) of 2005 in Upper middle income to that in Bangladesh?
Provide a succinct answer. 0.91. What is the ratio of the Rating (1=low 6=high) in 2006 in Upper middle income to that in Bangladesh?
Your response must be concise. 0.89. What is the ratio of the Rating (1=low 6=high) in 2008 in Upper middle income to that in Bangladesh?
Your answer should be very brief. 0.8. What is the ratio of the Rating (1=low 6=high) in 2005 in World to that in Bangladesh?
Provide a succinct answer. 0.89. What is the ratio of the Rating (1=low 6=high) of 2006 in World to that in Bangladesh?
Offer a terse response. 0.89. What is the ratio of the Rating (1=low 6=high) in 2007 in World to that in Bangladesh?
Offer a terse response. 0.89. What is the ratio of the Rating (1=low 6=high) of 2008 in World to that in Bangladesh?
Provide a short and direct response. 0.84. What is the difference between the highest and the second highest Rating (1=low 6=high) of 2005?
Provide a succinct answer. 0.12. What is the difference between the highest and the second highest Rating (1=low 6=high) in 2006?
Offer a terse response. 0.29. What is the difference between the highest and the second highest Rating (1=low 6=high) in 2007?
Give a very brief answer. 0.33. What is the difference between the highest and the second highest Rating (1=low 6=high) in 2008?
Offer a terse response. 0.66. What is the difference between the highest and the lowest Rating (1=low 6=high) of 2005?
Your response must be concise. 0.72. What is the difference between the highest and the lowest Rating (1=low 6=high) of 2006?
Ensure brevity in your answer.  0.71. What is the difference between the highest and the lowest Rating (1=low 6=high) of 2007?
Provide a short and direct response. 0.64. What is the difference between the highest and the lowest Rating (1=low 6=high) of 2008?
Keep it short and to the point. 0.84. 